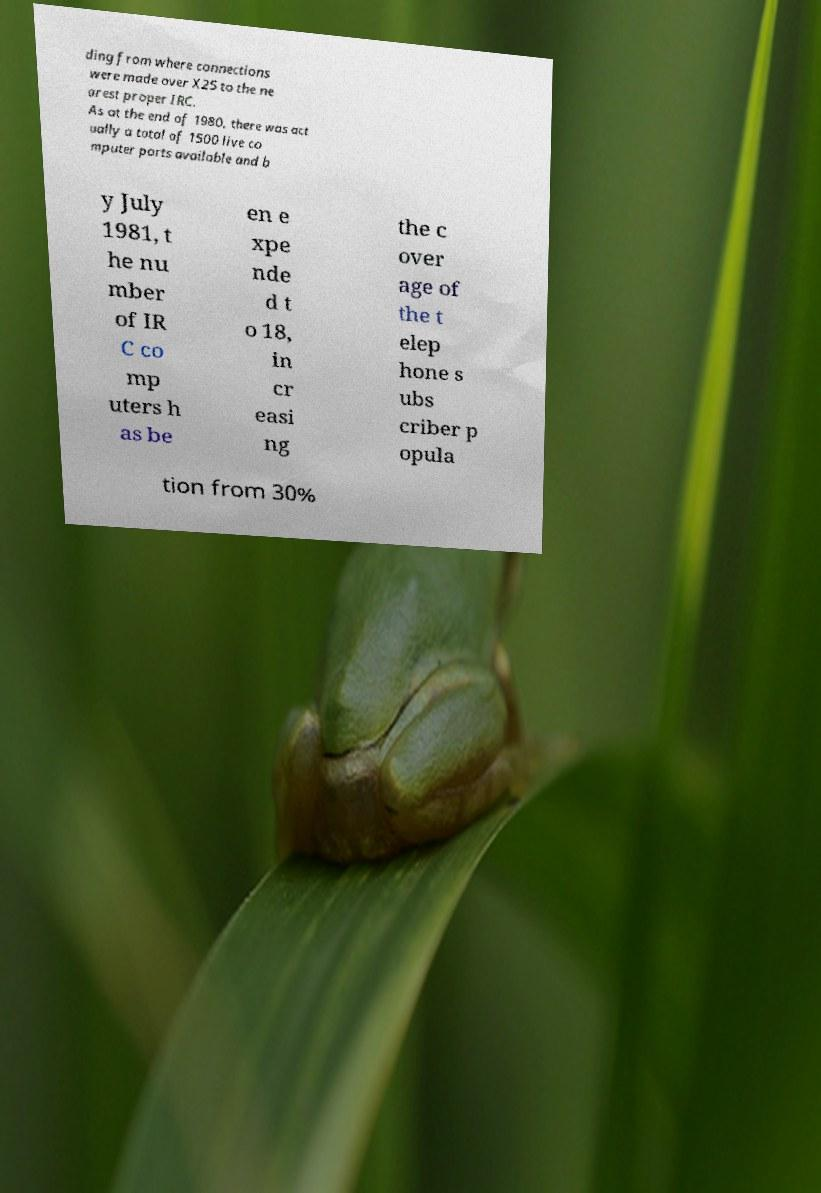Please read and relay the text visible in this image. What does it say? ding from where connections were made over X25 to the ne arest proper IRC. As at the end of 1980, there was act ually a total of 1500 live co mputer ports available and b y July 1981, t he nu mber of IR C co mp uters h as be en e xpe nde d t o 18, in cr easi ng the c over age of the t elep hone s ubs criber p opula tion from 30% 